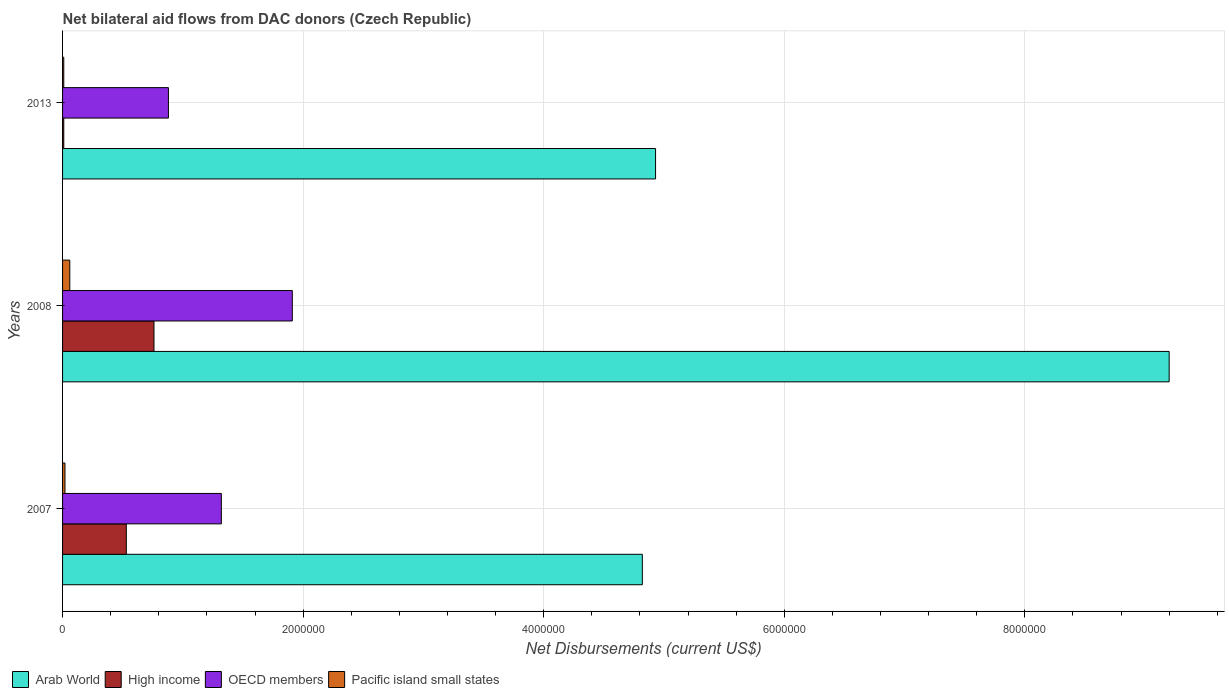How many groups of bars are there?
Provide a short and direct response. 3. How many bars are there on the 3rd tick from the top?
Offer a terse response. 4. How many bars are there on the 2nd tick from the bottom?
Offer a terse response. 4. What is the label of the 2nd group of bars from the top?
Your answer should be compact. 2008. In how many cases, is the number of bars for a given year not equal to the number of legend labels?
Make the answer very short. 0. Across all years, what is the maximum net bilateral aid flows in High income?
Keep it short and to the point. 7.60e+05. Across all years, what is the minimum net bilateral aid flows in OECD members?
Provide a succinct answer. 8.80e+05. In which year was the net bilateral aid flows in Arab World maximum?
Your answer should be compact. 2008. In which year was the net bilateral aid flows in OECD members minimum?
Provide a short and direct response. 2013. What is the total net bilateral aid flows in Arab World in the graph?
Keep it short and to the point. 1.90e+07. In the year 2008, what is the difference between the net bilateral aid flows in OECD members and net bilateral aid flows in High income?
Offer a very short reply. 1.15e+06. In how many years, is the net bilateral aid flows in OECD members greater than 7600000 US$?
Your response must be concise. 0. What is the difference between the highest and the lowest net bilateral aid flows in High income?
Your response must be concise. 7.50e+05. Is the sum of the net bilateral aid flows in OECD members in 2007 and 2013 greater than the maximum net bilateral aid flows in Pacific island small states across all years?
Your answer should be very brief. Yes. Is it the case that in every year, the sum of the net bilateral aid flows in OECD members and net bilateral aid flows in High income is greater than the sum of net bilateral aid flows in Arab World and net bilateral aid flows in Pacific island small states?
Your response must be concise. No. What does the 1st bar from the bottom in 2013 represents?
Offer a very short reply. Arab World. Are all the bars in the graph horizontal?
Make the answer very short. Yes. How many years are there in the graph?
Your answer should be compact. 3. What is the difference between two consecutive major ticks on the X-axis?
Make the answer very short. 2.00e+06. Does the graph contain grids?
Offer a terse response. Yes. What is the title of the graph?
Your answer should be very brief. Net bilateral aid flows from DAC donors (Czech Republic). Does "Mauritania" appear as one of the legend labels in the graph?
Provide a succinct answer. No. What is the label or title of the X-axis?
Offer a very short reply. Net Disbursements (current US$). What is the label or title of the Y-axis?
Offer a very short reply. Years. What is the Net Disbursements (current US$) of Arab World in 2007?
Keep it short and to the point. 4.82e+06. What is the Net Disbursements (current US$) of High income in 2007?
Your answer should be very brief. 5.30e+05. What is the Net Disbursements (current US$) in OECD members in 2007?
Keep it short and to the point. 1.32e+06. What is the Net Disbursements (current US$) in Pacific island small states in 2007?
Make the answer very short. 2.00e+04. What is the Net Disbursements (current US$) of Arab World in 2008?
Give a very brief answer. 9.20e+06. What is the Net Disbursements (current US$) of High income in 2008?
Provide a short and direct response. 7.60e+05. What is the Net Disbursements (current US$) of OECD members in 2008?
Offer a very short reply. 1.91e+06. What is the Net Disbursements (current US$) of Arab World in 2013?
Your answer should be compact. 4.93e+06. What is the Net Disbursements (current US$) of OECD members in 2013?
Keep it short and to the point. 8.80e+05. What is the Net Disbursements (current US$) in Pacific island small states in 2013?
Keep it short and to the point. 10000. Across all years, what is the maximum Net Disbursements (current US$) of Arab World?
Offer a terse response. 9.20e+06. Across all years, what is the maximum Net Disbursements (current US$) in High income?
Your response must be concise. 7.60e+05. Across all years, what is the maximum Net Disbursements (current US$) in OECD members?
Your answer should be compact. 1.91e+06. Across all years, what is the maximum Net Disbursements (current US$) in Pacific island small states?
Ensure brevity in your answer.  6.00e+04. Across all years, what is the minimum Net Disbursements (current US$) in Arab World?
Offer a terse response. 4.82e+06. Across all years, what is the minimum Net Disbursements (current US$) of OECD members?
Offer a very short reply. 8.80e+05. Across all years, what is the minimum Net Disbursements (current US$) in Pacific island small states?
Offer a terse response. 10000. What is the total Net Disbursements (current US$) in Arab World in the graph?
Your response must be concise. 1.90e+07. What is the total Net Disbursements (current US$) of High income in the graph?
Offer a terse response. 1.30e+06. What is the total Net Disbursements (current US$) in OECD members in the graph?
Your answer should be compact. 4.11e+06. What is the difference between the Net Disbursements (current US$) of Arab World in 2007 and that in 2008?
Give a very brief answer. -4.38e+06. What is the difference between the Net Disbursements (current US$) in OECD members in 2007 and that in 2008?
Your response must be concise. -5.90e+05. What is the difference between the Net Disbursements (current US$) of Pacific island small states in 2007 and that in 2008?
Provide a succinct answer. -4.00e+04. What is the difference between the Net Disbursements (current US$) in High income in 2007 and that in 2013?
Make the answer very short. 5.20e+05. What is the difference between the Net Disbursements (current US$) in Pacific island small states in 2007 and that in 2013?
Provide a succinct answer. 10000. What is the difference between the Net Disbursements (current US$) of Arab World in 2008 and that in 2013?
Provide a succinct answer. 4.27e+06. What is the difference between the Net Disbursements (current US$) in High income in 2008 and that in 2013?
Ensure brevity in your answer.  7.50e+05. What is the difference between the Net Disbursements (current US$) in OECD members in 2008 and that in 2013?
Offer a very short reply. 1.03e+06. What is the difference between the Net Disbursements (current US$) of Arab World in 2007 and the Net Disbursements (current US$) of High income in 2008?
Give a very brief answer. 4.06e+06. What is the difference between the Net Disbursements (current US$) in Arab World in 2007 and the Net Disbursements (current US$) in OECD members in 2008?
Your answer should be very brief. 2.91e+06. What is the difference between the Net Disbursements (current US$) in Arab World in 2007 and the Net Disbursements (current US$) in Pacific island small states in 2008?
Offer a very short reply. 4.76e+06. What is the difference between the Net Disbursements (current US$) in High income in 2007 and the Net Disbursements (current US$) in OECD members in 2008?
Give a very brief answer. -1.38e+06. What is the difference between the Net Disbursements (current US$) in High income in 2007 and the Net Disbursements (current US$) in Pacific island small states in 2008?
Offer a terse response. 4.70e+05. What is the difference between the Net Disbursements (current US$) in OECD members in 2007 and the Net Disbursements (current US$) in Pacific island small states in 2008?
Your response must be concise. 1.26e+06. What is the difference between the Net Disbursements (current US$) in Arab World in 2007 and the Net Disbursements (current US$) in High income in 2013?
Offer a very short reply. 4.81e+06. What is the difference between the Net Disbursements (current US$) of Arab World in 2007 and the Net Disbursements (current US$) of OECD members in 2013?
Make the answer very short. 3.94e+06. What is the difference between the Net Disbursements (current US$) in Arab World in 2007 and the Net Disbursements (current US$) in Pacific island small states in 2013?
Provide a short and direct response. 4.81e+06. What is the difference between the Net Disbursements (current US$) of High income in 2007 and the Net Disbursements (current US$) of OECD members in 2013?
Keep it short and to the point. -3.50e+05. What is the difference between the Net Disbursements (current US$) in High income in 2007 and the Net Disbursements (current US$) in Pacific island small states in 2013?
Ensure brevity in your answer.  5.20e+05. What is the difference between the Net Disbursements (current US$) of OECD members in 2007 and the Net Disbursements (current US$) of Pacific island small states in 2013?
Your answer should be very brief. 1.31e+06. What is the difference between the Net Disbursements (current US$) of Arab World in 2008 and the Net Disbursements (current US$) of High income in 2013?
Give a very brief answer. 9.19e+06. What is the difference between the Net Disbursements (current US$) of Arab World in 2008 and the Net Disbursements (current US$) of OECD members in 2013?
Offer a very short reply. 8.32e+06. What is the difference between the Net Disbursements (current US$) in Arab World in 2008 and the Net Disbursements (current US$) in Pacific island small states in 2013?
Your answer should be very brief. 9.19e+06. What is the difference between the Net Disbursements (current US$) in High income in 2008 and the Net Disbursements (current US$) in Pacific island small states in 2013?
Offer a very short reply. 7.50e+05. What is the difference between the Net Disbursements (current US$) in OECD members in 2008 and the Net Disbursements (current US$) in Pacific island small states in 2013?
Provide a short and direct response. 1.90e+06. What is the average Net Disbursements (current US$) in Arab World per year?
Your answer should be very brief. 6.32e+06. What is the average Net Disbursements (current US$) of High income per year?
Offer a very short reply. 4.33e+05. What is the average Net Disbursements (current US$) of OECD members per year?
Your answer should be compact. 1.37e+06. In the year 2007, what is the difference between the Net Disbursements (current US$) in Arab World and Net Disbursements (current US$) in High income?
Provide a short and direct response. 4.29e+06. In the year 2007, what is the difference between the Net Disbursements (current US$) of Arab World and Net Disbursements (current US$) of OECD members?
Provide a succinct answer. 3.50e+06. In the year 2007, what is the difference between the Net Disbursements (current US$) in Arab World and Net Disbursements (current US$) in Pacific island small states?
Your response must be concise. 4.80e+06. In the year 2007, what is the difference between the Net Disbursements (current US$) of High income and Net Disbursements (current US$) of OECD members?
Your answer should be compact. -7.90e+05. In the year 2007, what is the difference between the Net Disbursements (current US$) of High income and Net Disbursements (current US$) of Pacific island small states?
Offer a very short reply. 5.10e+05. In the year 2007, what is the difference between the Net Disbursements (current US$) in OECD members and Net Disbursements (current US$) in Pacific island small states?
Your answer should be very brief. 1.30e+06. In the year 2008, what is the difference between the Net Disbursements (current US$) in Arab World and Net Disbursements (current US$) in High income?
Your response must be concise. 8.44e+06. In the year 2008, what is the difference between the Net Disbursements (current US$) in Arab World and Net Disbursements (current US$) in OECD members?
Your answer should be compact. 7.29e+06. In the year 2008, what is the difference between the Net Disbursements (current US$) of Arab World and Net Disbursements (current US$) of Pacific island small states?
Your response must be concise. 9.14e+06. In the year 2008, what is the difference between the Net Disbursements (current US$) of High income and Net Disbursements (current US$) of OECD members?
Give a very brief answer. -1.15e+06. In the year 2008, what is the difference between the Net Disbursements (current US$) of High income and Net Disbursements (current US$) of Pacific island small states?
Give a very brief answer. 7.00e+05. In the year 2008, what is the difference between the Net Disbursements (current US$) of OECD members and Net Disbursements (current US$) of Pacific island small states?
Offer a terse response. 1.85e+06. In the year 2013, what is the difference between the Net Disbursements (current US$) of Arab World and Net Disbursements (current US$) of High income?
Your answer should be very brief. 4.92e+06. In the year 2013, what is the difference between the Net Disbursements (current US$) of Arab World and Net Disbursements (current US$) of OECD members?
Your response must be concise. 4.05e+06. In the year 2013, what is the difference between the Net Disbursements (current US$) of Arab World and Net Disbursements (current US$) of Pacific island small states?
Provide a short and direct response. 4.92e+06. In the year 2013, what is the difference between the Net Disbursements (current US$) of High income and Net Disbursements (current US$) of OECD members?
Keep it short and to the point. -8.70e+05. In the year 2013, what is the difference between the Net Disbursements (current US$) of High income and Net Disbursements (current US$) of Pacific island small states?
Keep it short and to the point. 0. In the year 2013, what is the difference between the Net Disbursements (current US$) in OECD members and Net Disbursements (current US$) in Pacific island small states?
Your answer should be very brief. 8.70e+05. What is the ratio of the Net Disbursements (current US$) in Arab World in 2007 to that in 2008?
Provide a short and direct response. 0.52. What is the ratio of the Net Disbursements (current US$) in High income in 2007 to that in 2008?
Keep it short and to the point. 0.7. What is the ratio of the Net Disbursements (current US$) of OECD members in 2007 to that in 2008?
Offer a terse response. 0.69. What is the ratio of the Net Disbursements (current US$) of Arab World in 2007 to that in 2013?
Your answer should be very brief. 0.98. What is the ratio of the Net Disbursements (current US$) of OECD members in 2007 to that in 2013?
Keep it short and to the point. 1.5. What is the ratio of the Net Disbursements (current US$) of Pacific island small states in 2007 to that in 2013?
Offer a very short reply. 2. What is the ratio of the Net Disbursements (current US$) in Arab World in 2008 to that in 2013?
Ensure brevity in your answer.  1.87. What is the ratio of the Net Disbursements (current US$) in OECD members in 2008 to that in 2013?
Your answer should be very brief. 2.17. What is the ratio of the Net Disbursements (current US$) in Pacific island small states in 2008 to that in 2013?
Offer a very short reply. 6. What is the difference between the highest and the second highest Net Disbursements (current US$) in Arab World?
Offer a very short reply. 4.27e+06. What is the difference between the highest and the second highest Net Disbursements (current US$) of High income?
Ensure brevity in your answer.  2.30e+05. What is the difference between the highest and the second highest Net Disbursements (current US$) of OECD members?
Give a very brief answer. 5.90e+05. What is the difference between the highest and the second highest Net Disbursements (current US$) of Pacific island small states?
Your response must be concise. 4.00e+04. What is the difference between the highest and the lowest Net Disbursements (current US$) in Arab World?
Provide a short and direct response. 4.38e+06. What is the difference between the highest and the lowest Net Disbursements (current US$) in High income?
Ensure brevity in your answer.  7.50e+05. What is the difference between the highest and the lowest Net Disbursements (current US$) of OECD members?
Offer a very short reply. 1.03e+06. What is the difference between the highest and the lowest Net Disbursements (current US$) in Pacific island small states?
Your answer should be compact. 5.00e+04. 